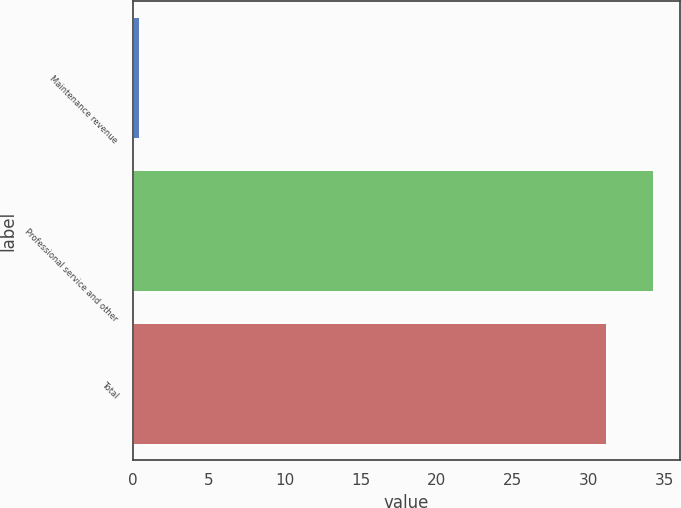<chart> <loc_0><loc_0><loc_500><loc_500><bar_chart><fcel>Maintenance revenue<fcel>Professional service and other<fcel>Total<nl><fcel>0.5<fcel>34.32<fcel>31.2<nl></chart> 